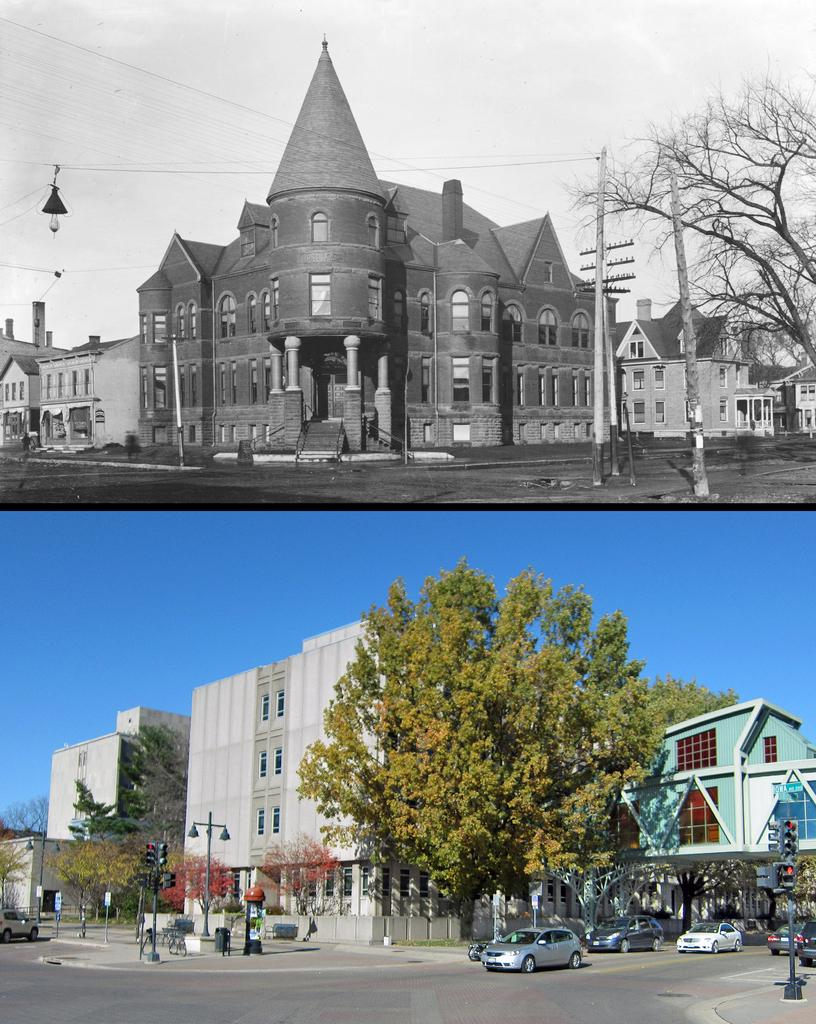What can be seen in the foreground of the image? In the foreground of the image, there are fleets of cars, poles, wires, trees on the road, and buildings. What is visible in the background of the image? The sky is visible in the background of the image. When was the image taken? The image was taken during the day. What type of humor can be seen in the image? There is no humor present in the image; it is a photograph of fleets of cars, poles, wires, trees on the road, buildings, and the sky. Is there a sidewalk visible in the image? There is no sidewalk mentioned in the provided facts, so it cannot be determined if one is present in the image. 